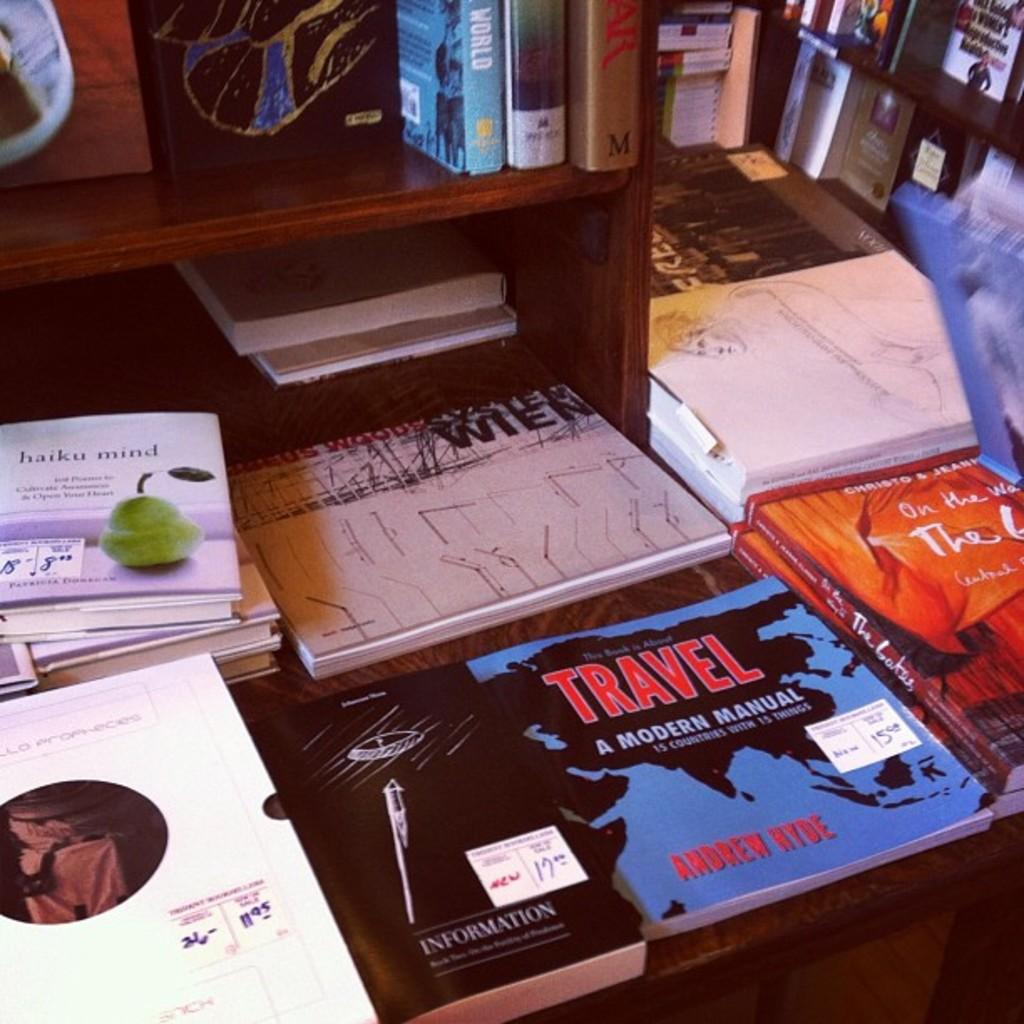<image>
Render a clear and concise summary of the photo. the word travel is on one of the cd's 